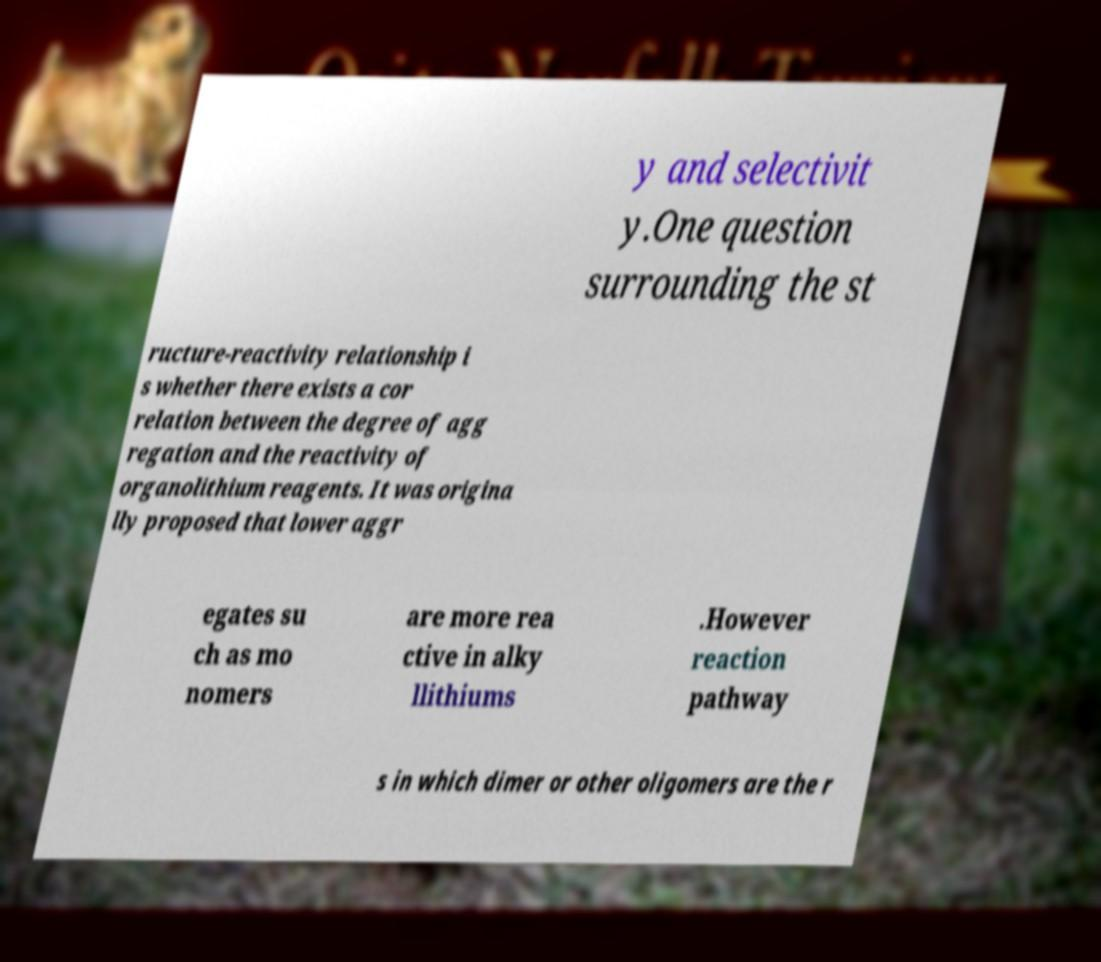What messages or text are displayed in this image? I need them in a readable, typed format. y and selectivit y.One question surrounding the st ructure-reactivity relationship i s whether there exists a cor relation between the degree of agg regation and the reactivity of organolithium reagents. It was origina lly proposed that lower aggr egates su ch as mo nomers are more rea ctive in alky llithiums .However reaction pathway s in which dimer or other oligomers are the r 